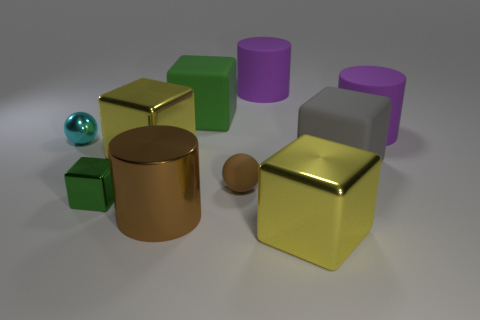Subtract all big metallic blocks. How many blocks are left? 3 Subtract all brown balls. How many balls are left? 1 Subtract all green cubes. Subtract all yellow balls. How many cubes are left? 3 Subtract all brown blocks. How many cyan balls are left? 1 Subtract all big yellow metallic cubes. Subtract all small cyan objects. How many objects are left? 7 Add 1 rubber balls. How many rubber balls are left? 2 Add 2 yellow metallic blocks. How many yellow metallic blocks exist? 4 Subtract 1 brown spheres. How many objects are left? 9 Subtract all balls. How many objects are left? 8 Subtract 2 cylinders. How many cylinders are left? 1 